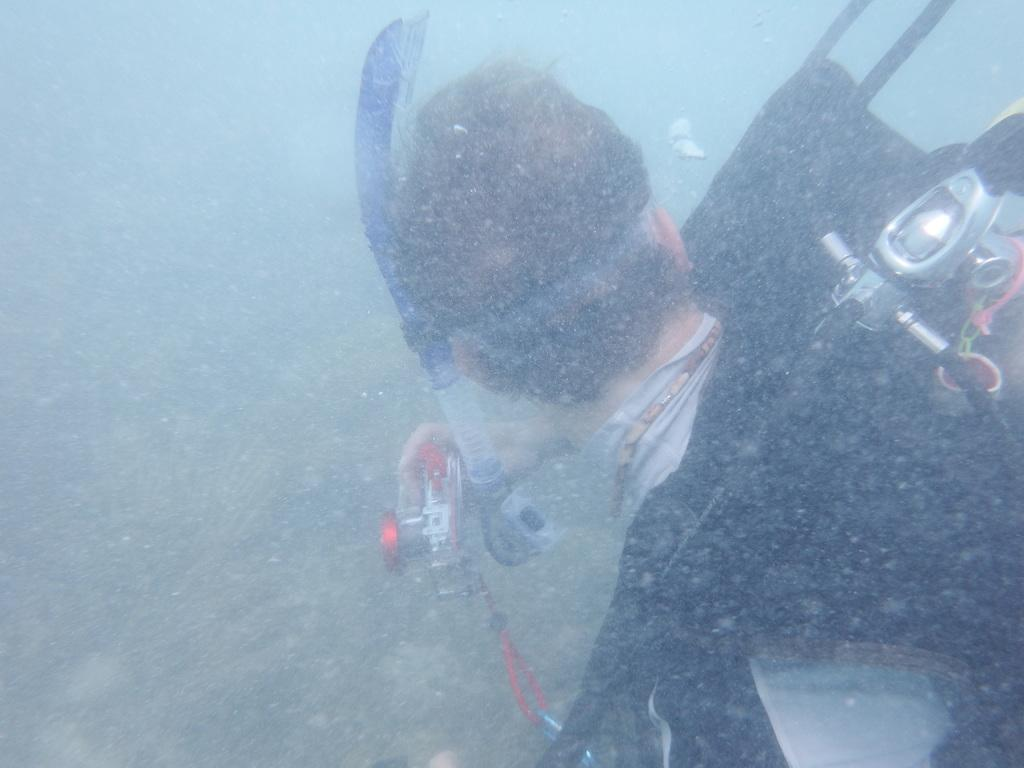What can be seen in the image? There is a person in the image. Can you describe the person's attire? The person is wearing a black and ash color dress. What is the person holding in the image? The person is holding an object. Where is the person located in the image? The person is in the water. What type of lettuce can be seen growing in the water near the person? There is no lettuce present in the image; the person is in the water, but there is no mention of lettuce or any other vegetation. 